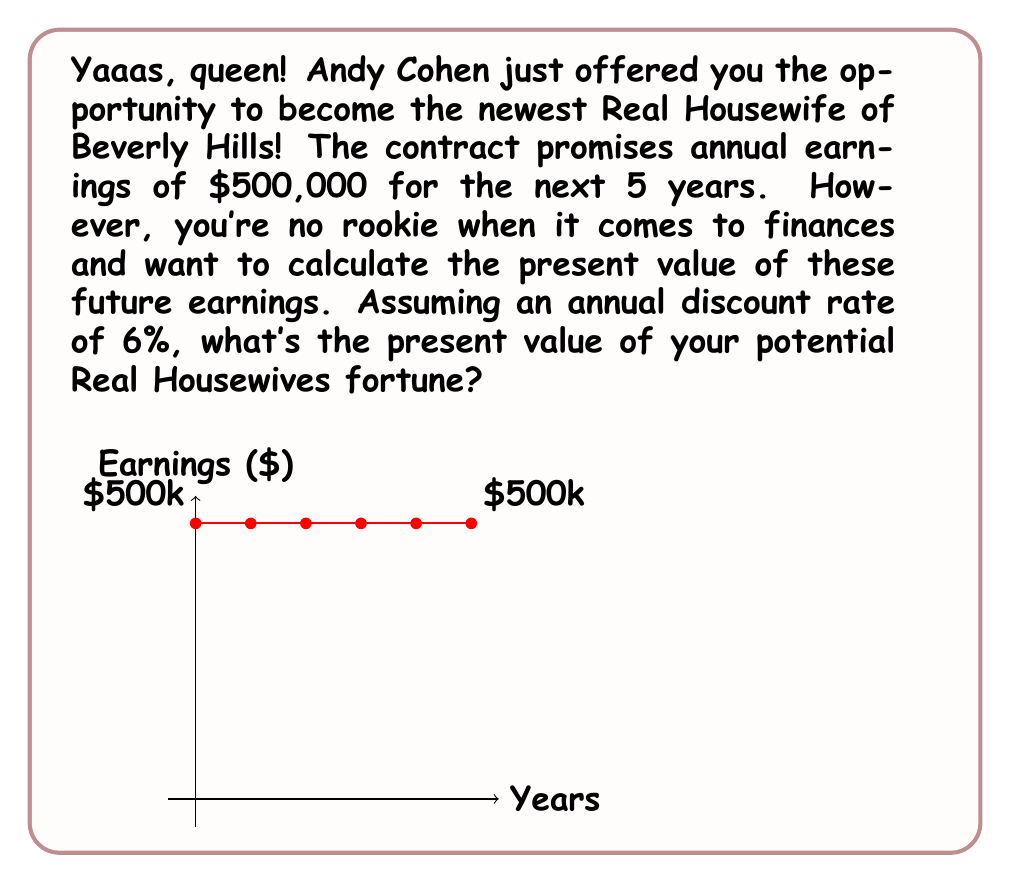Show me your answer to this math problem. Let's break this down step-by-step, honey!

1) We're dealing with an annuity here - a series of equal payments over a fixed period. The formula for the present value of an annuity is:

   $$PV = PMT \times \frac{1 - (1+r)^{-n}}{r}$$

   Where:
   PV = Present Value
   PMT = Payment (annual earnings)
   r = Discount rate
   n = Number of periods (years)

2) Let's plug in our values:
   PMT = $500,000
   r = 6% = 0.06
   n = 5 years

3) Now, let's calculate:

   $$PV = 500,000 \times \frac{1 - (1+0.06)^{-5}}{0.06}$$

4) Let's solve the exponent first:
   $$(1+0.06)^{-5} = 0.7472$$

5) Now our equation looks like:

   $$PV = 500,000 \times \frac{1 - 0.7472}{0.06}$$

6) Simplify:

   $$PV = 500,000 \times \frac{0.2528}{0.06} = 500,000 \times 4.2133$$

7) Final calculation:

   $$PV = 2,106,650$$

So, the present value of your potential Real Housewives fortune is $2,106,650. That's a lot of diamonds and rosé, darling!
Answer: $2,106,650 